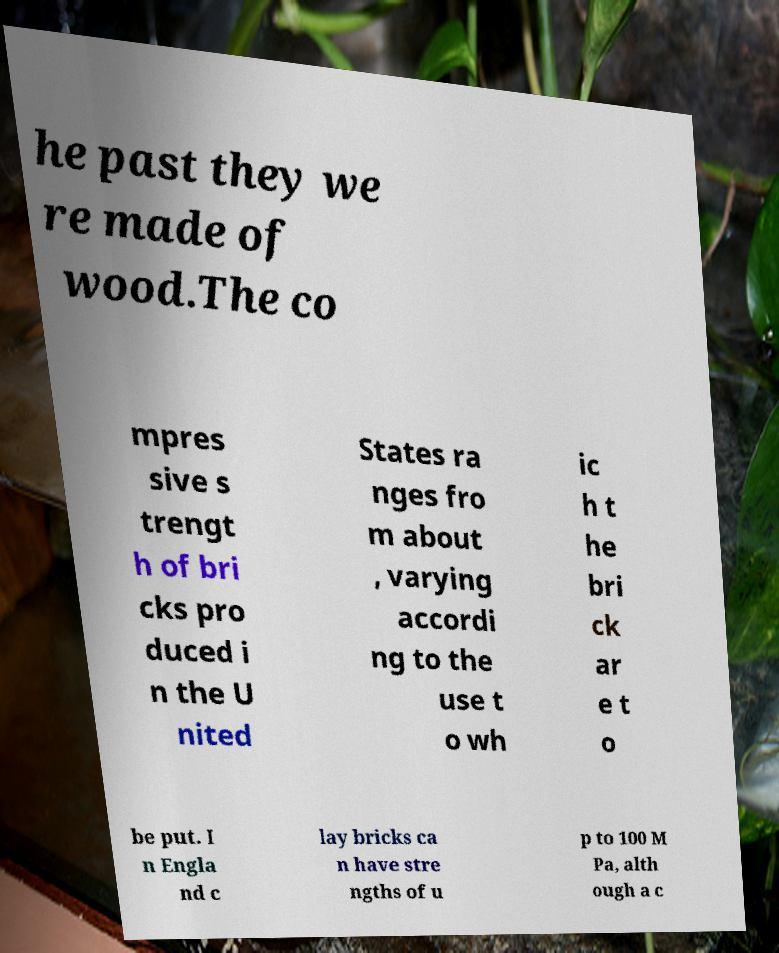For documentation purposes, I need the text within this image transcribed. Could you provide that? he past they we re made of wood.The co mpres sive s trengt h of bri cks pro duced i n the U nited States ra nges fro m about , varying accordi ng to the use t o wh ic h t he bri ck ar e t o be put. I n Engla nd c lay bricks ca n have stre ngths of u p to 100 M Pa, alth ough a c 